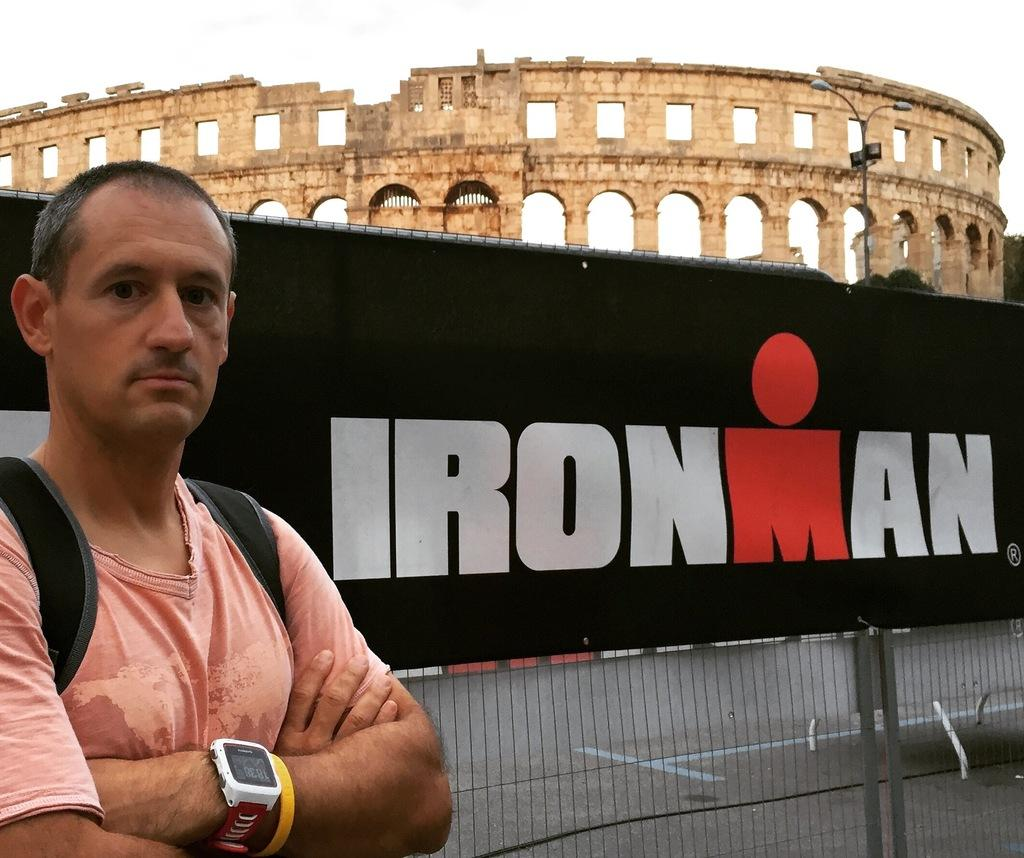<image>
Render a clear and concise summary of the photo. a person standing in front of the Roman Colosseum and Ironman sign 